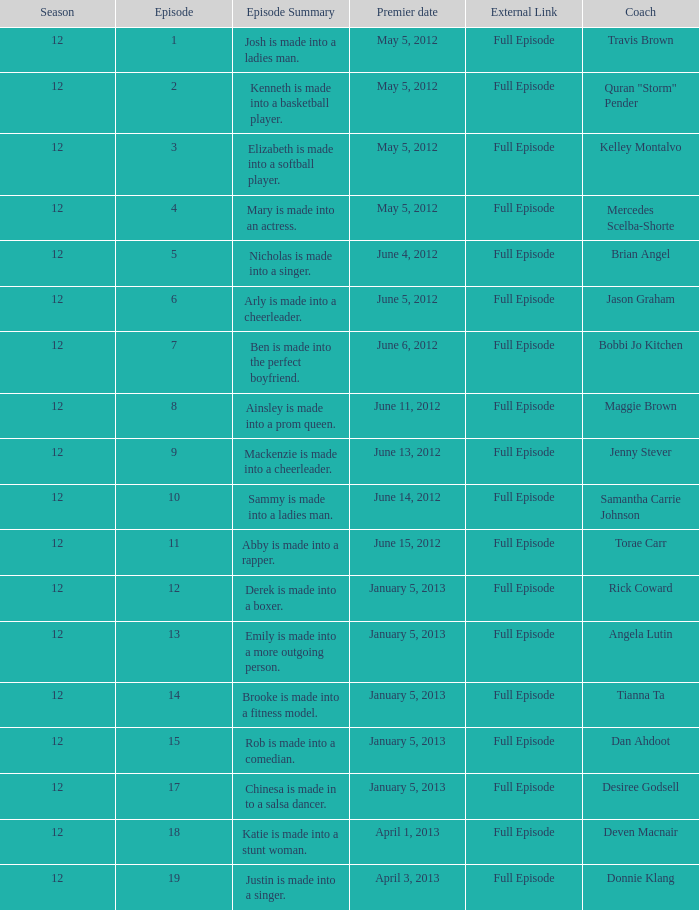Name the least episode for donnie klang 19.0. 